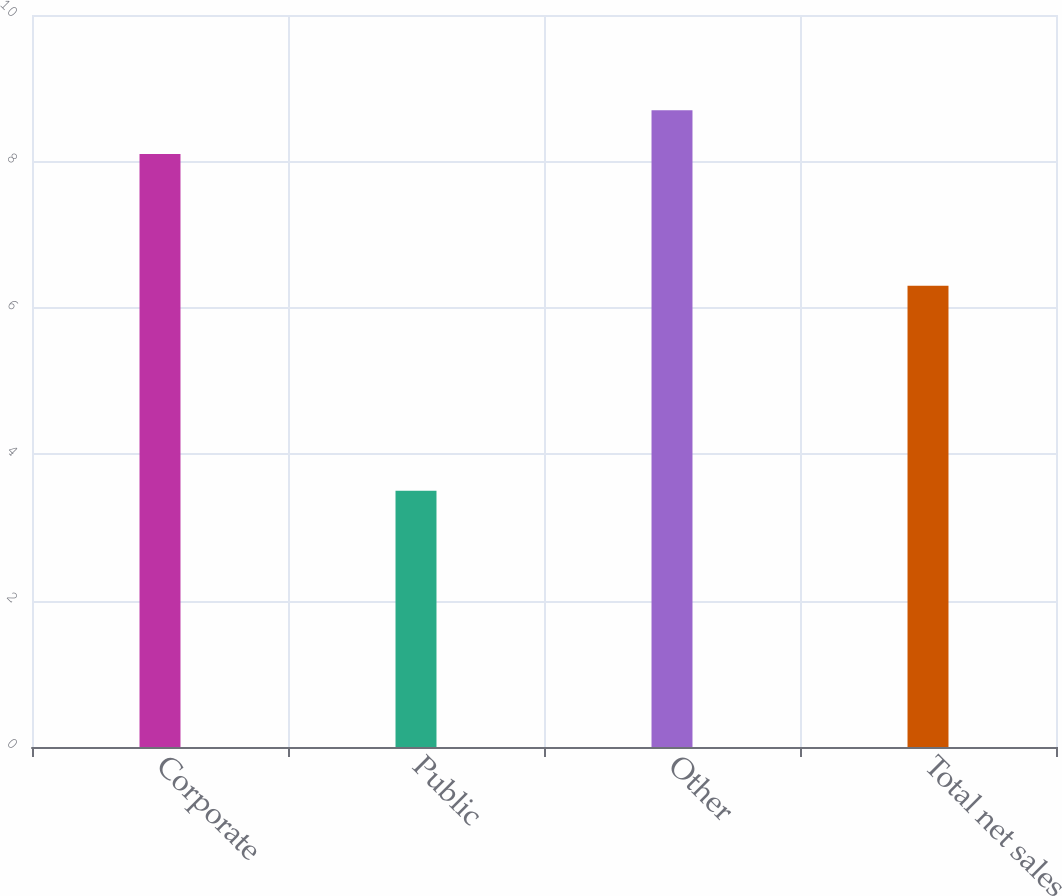Convert chart. <chart><loc_0><loc_0><loc_500><loc_500><bar_chart><fcel>Corporate<fcel>Public<fcel>Other<fcel>Total net sales<nl><fcel>8.1<fcel>3.5<fcel>8.7<fcel>6.3<nl></chart> 